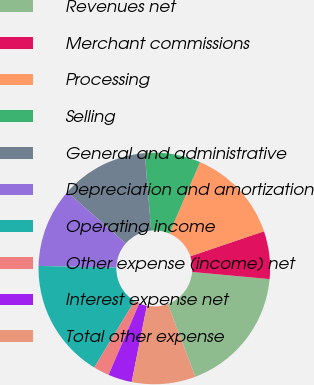Convert chart. <chart><loc_0><loc_0><loc_500><loc_500><pie_chart><fcel>Revenues net<fcel>Merchant commissions<fcel>Processing<fcel>Selling<fcel>General and administrative<fcel>Depreciation and amortization<fcel>Operating income<fcel>Other expense (income) net<fcel>Interest expense net<fcel>Total other expense<nl><fcel>17.78%<fcel>6.67%<fcel>13.33%<fcel>7.78%<fcel>12.22%<fcel>11.11%<fcel>16.67%<fcel>2.22%<fcel>3.33%<fcel>8.89%<nl></chart> 